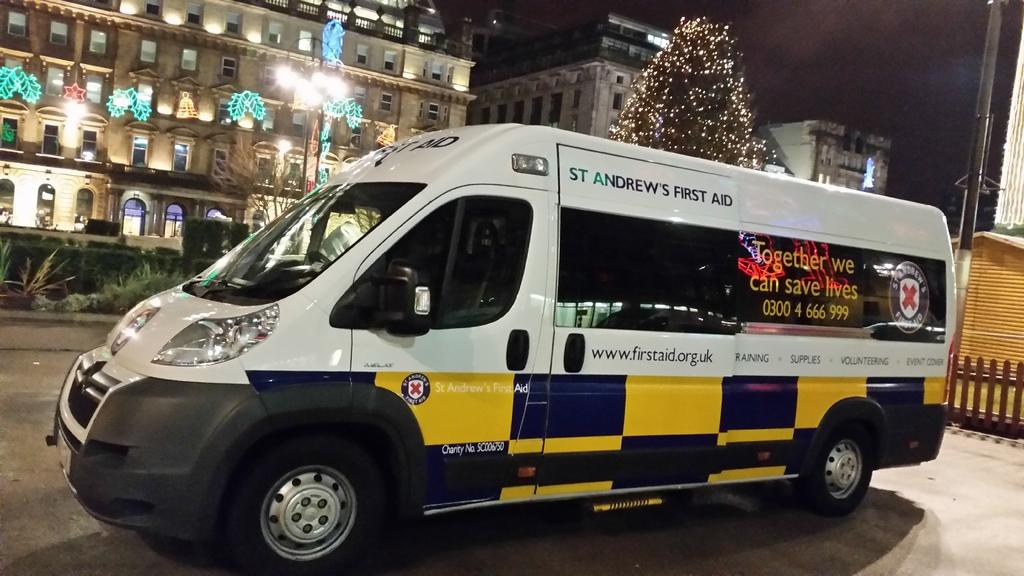What is the website link on this van?
Your response must be concise. Www.firstaid.org.uk. What phone number is seen on the window?
Offer a terse response. 0300 4 666 999. 